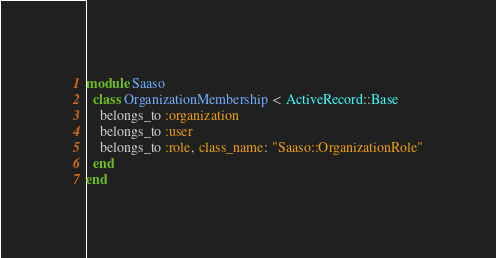Convert code to text. <code><loc_0><loc_0><loc_500><loc_500><_Ruby_>module Saaso
  class OrganizationMembership < ActiveRecord::Base
    belongs_to :organization
    belongs_to :user
    belongs_to :role, class_name: "Saaso::OrganizationRole"
  end
end
</code> 